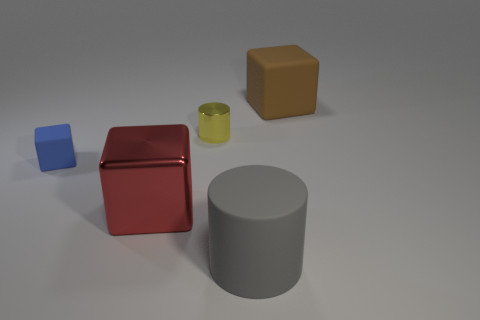What shapes can you identify in the image? In the image, there's a diversity of shapes that includes a cube for the red metal object, a rectangular prism for the blue rubber block, a cylinder for the gray object, and the yellow metal object appears to be an upright rectangular prism as well. Do the objects seem to serve a purpose? Without additional context, it's not clear if the objects serve a specific functional purpose. They could potentially be used for educational demonstrations of geometry, physical properties of materials, or as part of a visual composition in an art or design setting. 